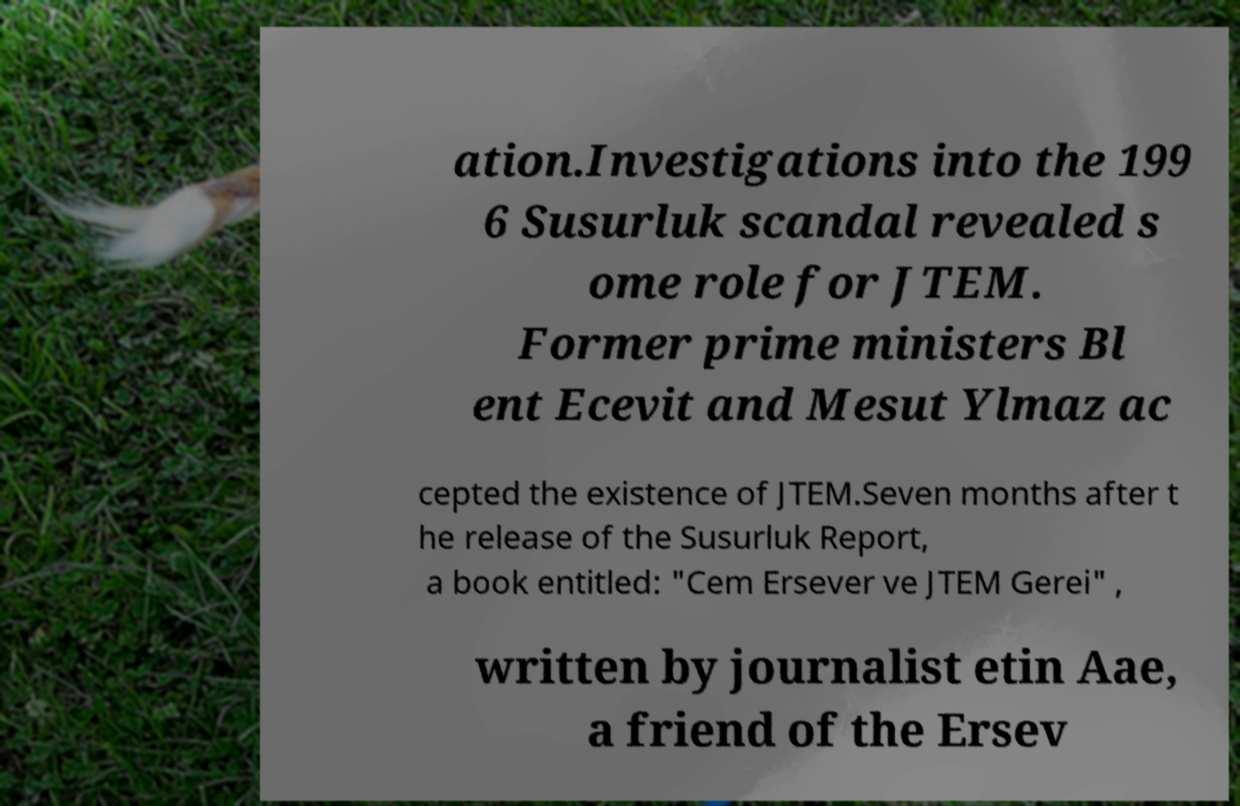I need the written content from this picture converted into text. Can you do that? ation.Investigations into the 199 6 Susurluk scandal revealed s ome role for JTEM. Former prime ministers Bl ent Ecevit and Mesut Ylmaz ac cepted the existence of JTEM.Seven months after t he release of the Susurluk Report, a book entitled: "Cem Ersever ve JTEM Gerei" , written by journalist etin Aae, a friend of the Ersev 